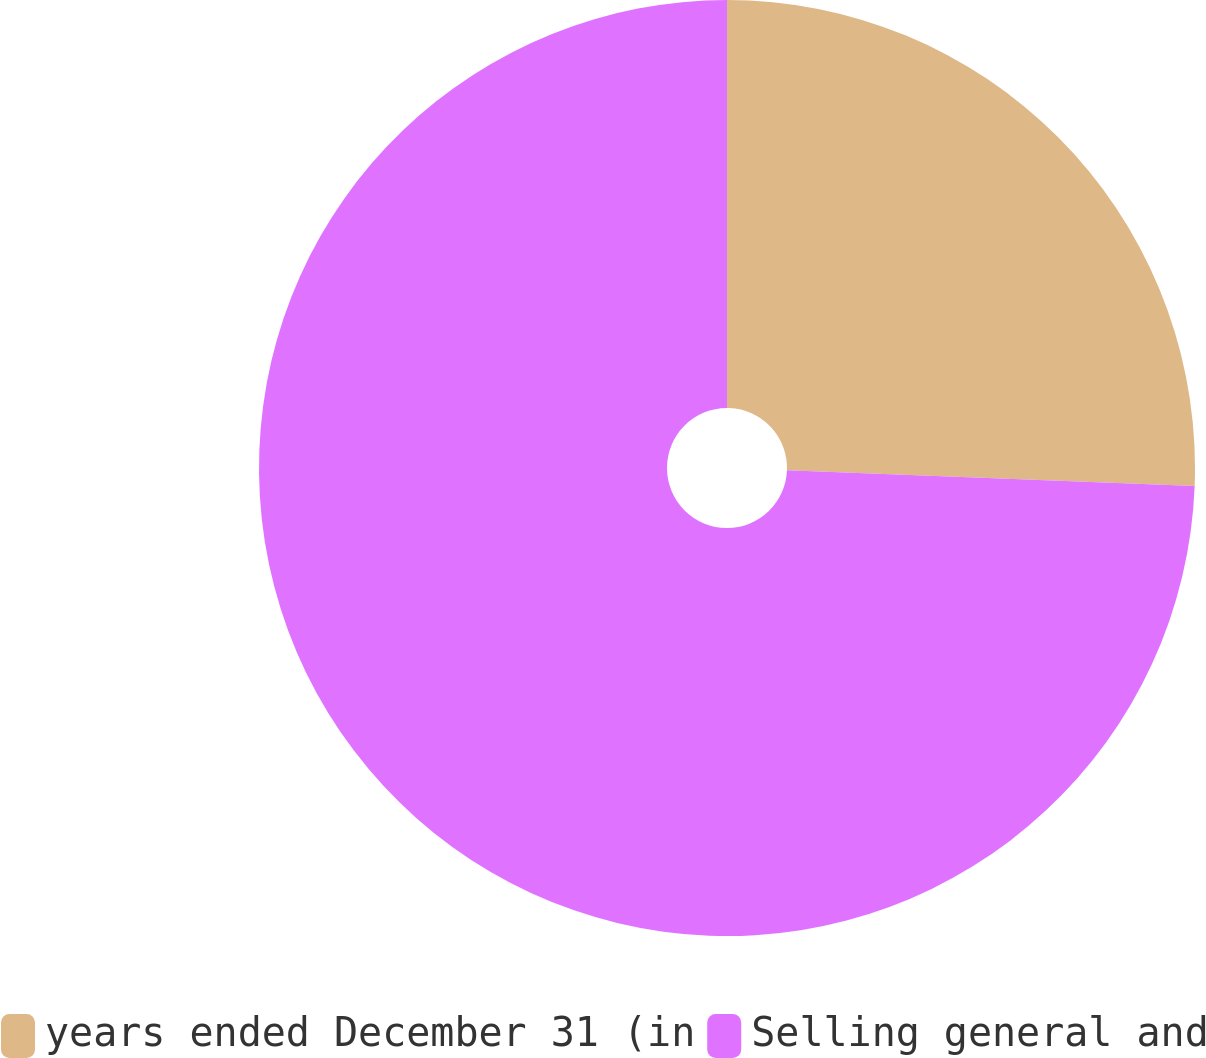<chart> <loc_0><loc_0><loc_500><loc_500><pie_chart><fcel>years ended December 31 (in<fcel>Selling general and<nl><fcel>25.61%<fcel>74.39%<nl></chart> 